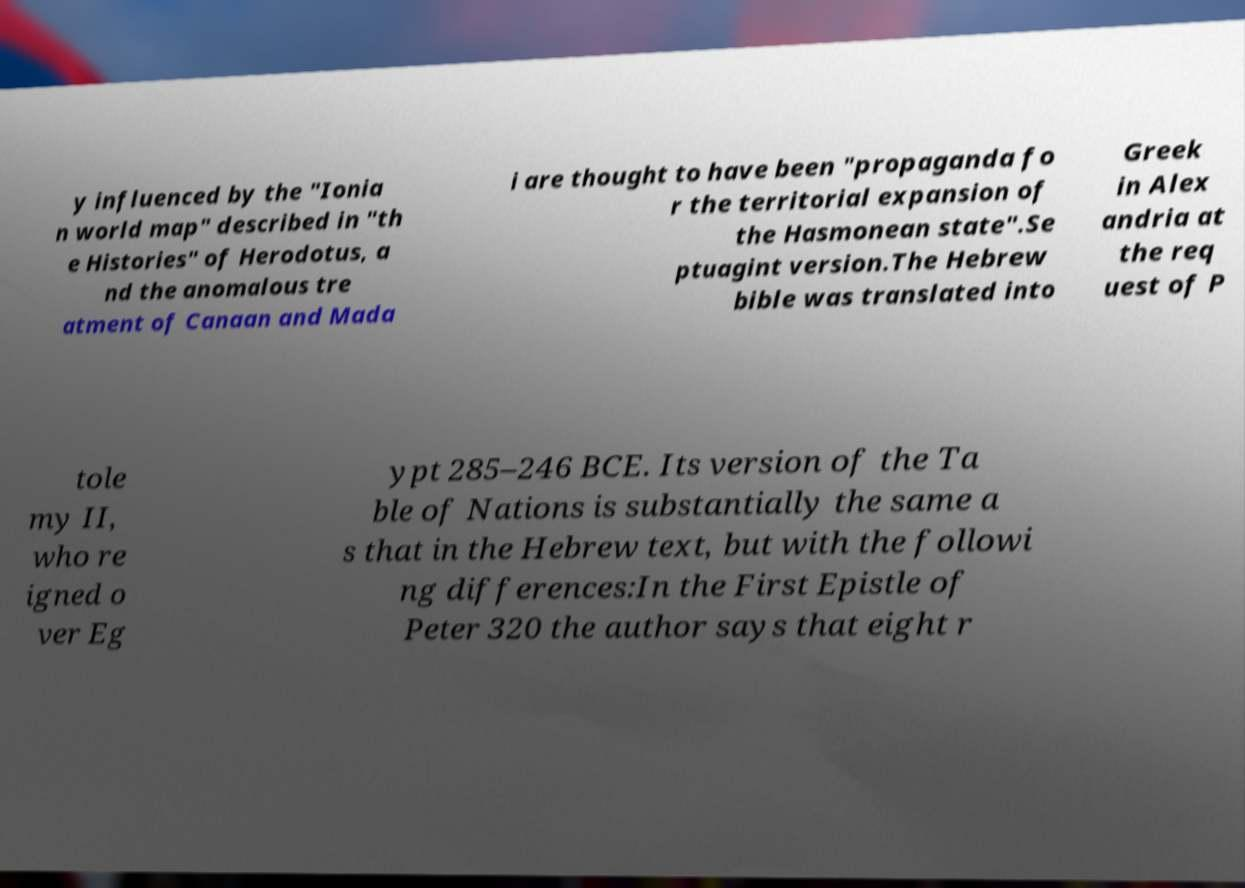Please identify and transcribe the text found in this image. y influenced by the "Ionia n world map" described in "th e Histories" of Herodotus, a nd the anomalous tre atment of Canaan and Mada i are thought to have been "propaganda fo r the territorial expansion of the Hasmonean state".Se ptuagint version.The Hebrew bible was translated into Greek in Alex andria at the req uest of P tole my II, who re igned o ver Eg ypt 285–246 BCE. Its version of the Ta ble of Nations is substantially the same a s that in the Hebrew text, but with the followi ng differences:In the First Epistle of Peter 320 the author says that eight r 